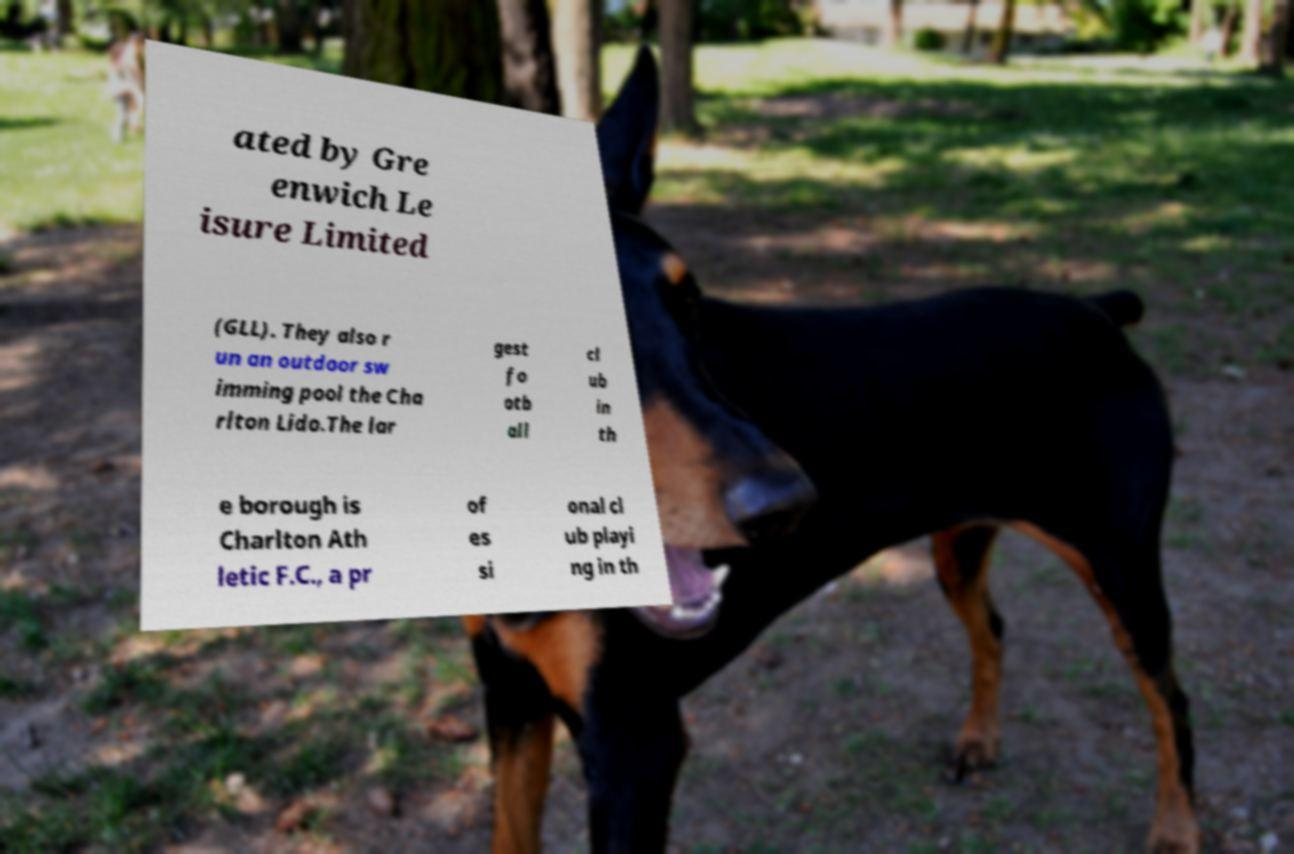What messages or text are displayed in this image? I need them in a readable, typed format. ated by Gre enwich Le isure Limited (GLL). They also r un an outdoor sw imming pool the Cha rlton Lido.The lar gest fo otb all cl ub in th e borough is Charlton Ath letic F.C., a pr of es si onal cl ub playi ng in th 